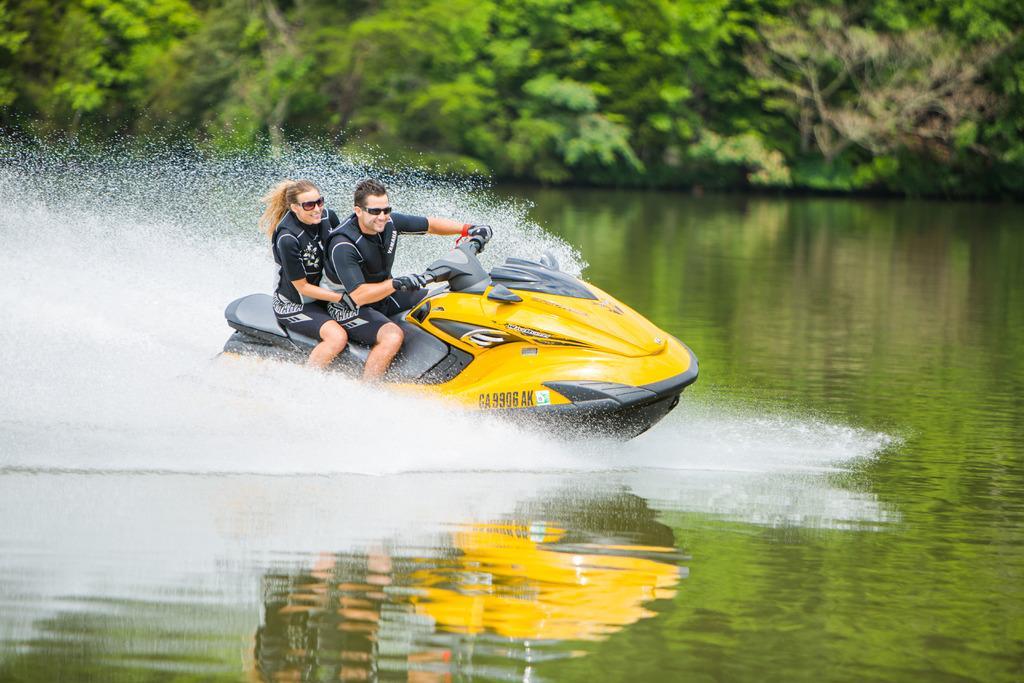In one or two sentences, can you explain what this image depicts? In the picture I can see two persons wearing life jackets and glasses are sitting on the water bike which is floating on the water. The background of the image is blurred, where we can see the trees. 